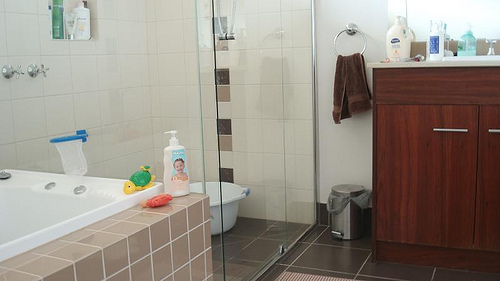Please provide a short description for this region: [0.31, 0.48, 0.39, 0.61]. Blue and white container placed on the corner of a bathtub. 